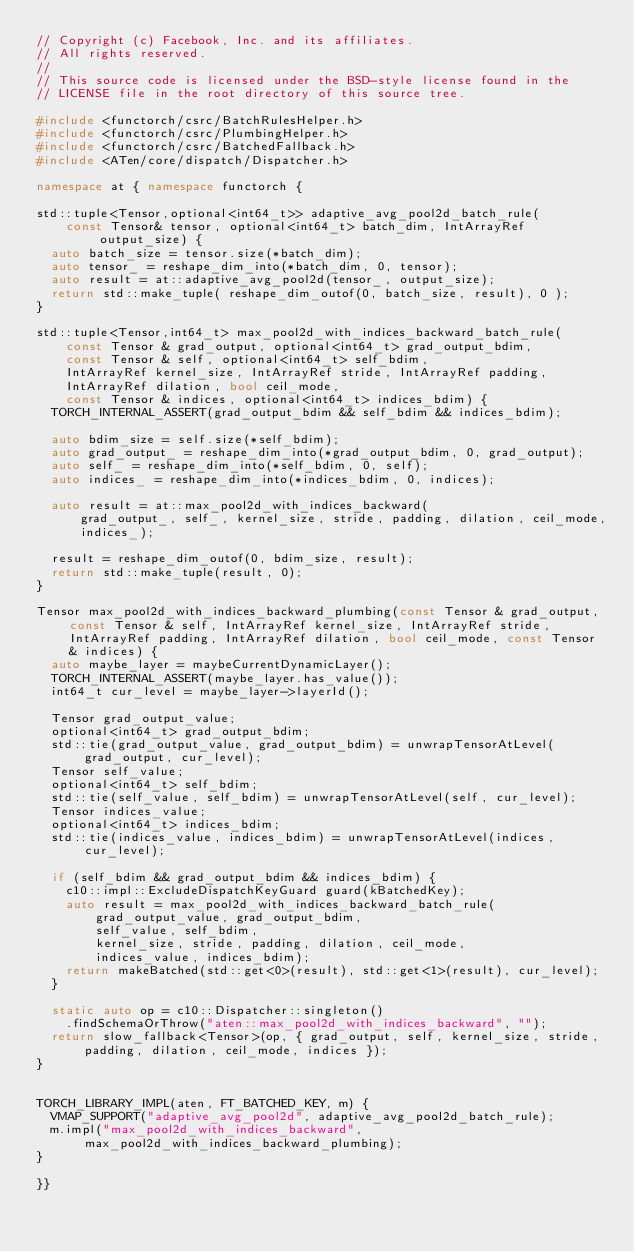<code> <loc_0><loc_0><loc_500><loc_500><_C++_>// Copyright (c) Facebook, Inc. and its affiliates.
// All rights reserved.
//
// This source code is licensed under the BSD-style license found in the
// LICENSE file in the root directory of this source tree.

#include <functorch/csrc/BatchRulesHelper.h>
#include <functorch/csrc/PlumbingHelper.h>
#include <functorch/csrc/BatchedFallback.h>
#include <ATen/core/dispatch/Dispatcher.h>

namespace at { namespace functorch {

std::tuple<Tensor,optional<int64_t>> adaptive_avg_pool2d_batch_rule(
    const Tensor& tensor, optional<int64_t> batch_dim, IntArrayRef output_size) {
  auto batch_size = tensor.size(*batch_dim);
  auto tensor_ = reshape_dim_into(*batch_dim, 0, tensor);
  auto result = at::adaptive_avg_pool2d(tensor_, output_size);
  return std::make_tuple( reshape_dim_outof(0, batch_size, result), 0 );
}

std::tuple<Tensor,int64_t> max_pool2d_with_indices_backward_batch_rule(
    const Tensor & grad_output, optional<int64_t> grad_output_bdim,
    const Tensor & self, optional<int64_t> self_bdim,
    IntArrayRef kernel_size, IntArrayRef stride, IntArrayRef padding,
    IntArrayRef dilation, bool ceil_mode,
    const Tensor & indices, optional<int64_t> indices_bdim) {
  TORCH_INTERNAL_ASSERT(grad_output_bdim && self_bdim && indices_bdim);

  auto bdim_size = self.size(*self_bdim);
  auto grad_output_ = reshape_dim_into(*grad_output_bdim, 0, grad_output);
  auto self_ = reshape_dim_into(*self_bdim, 0, self);
  auto indices_ = reshape_dim_into(*indices_bdim, 0, indices);

  auto result = at::max_pool2d_with_indices_backward(
      grad_output_, self_, kernel_size, stride, padding, dilation, ceil_mode,
      indices_);

  result = reshape_dim_outof(0, bdim_size, result);
  return std::make_tuple(result, 0);
}

Tensor max_pool2d_with_indices_backward_plumbing(const Tensor & grad_output, const Tensor & self, IntArrayRef kernel_size, IntArrayRef stride, IntArrayRef padding, IntArrayRef dilation, bool ceil_mode, const Tensor & indices) {
  auto maybe_layer = maybeCurrentDynamicLayer();
  TORCH_INTERNAL_ASSERT(maybe_layer.has_value());
  int64_t cur_level = maybe_layer->layerId();

  Tensor grad_output_value;
  optional<int64_t> grad_output_bdim;
  std::tie(grad_output_value, grad_output_bdim) = unwrapTensorAtLevel(grad_output, cur_level);
  Tensor self_value;
  optional<int64_t> self_bdim;
  std::tie(self_value, self_bdim) = unwrapTensorAtLevel(self, cur_level);
  Tensor indices_value;
  optional<int64_t> indices_bdim;
  std::tie(indices_value, indices_bdim) = unwrapTensorAtLevel(indices, cur_level);

  if (self_bdim && grad_output_bdim && indices_bdim) {
    c10::impl::ExcludeDispatchKeyGuard guard(kBatchedKey);
    auto result = max_pool2d_with_indices_backward_batch_rule(
        grad_output_value, grad_output_bdim,
        self_value, self_bdim,
        kernel_size, stride, padding, dilation, ceil_mode,
        indices_value, indices_bdim);
    return makeBatched(std::get<0>(result), std::get<1>(result), cur_level);
  }

  static auto op = c10::Dispatcher::singleton()
    .findSchemaOrThrow("aten::max_pool2d_with_indices_backward", "");
  return slow_fallback<Tensor>(op, { grad_output, self, kernel_size, stride, padding, dilation, ceil_mode, indices });
}


TORCH_LIBRARY_IMPL(aten, FT_BATCHED_KEY, m) {
  VMAP_SUPPORT("adaptive_avg_pool2d", adaptive_avg_pool2d_batch_rule);
  m.impl("max_pool2d_with_indices_backward", max_pool2d_with_indices_backward_plumbing);
}

}}
</code> 